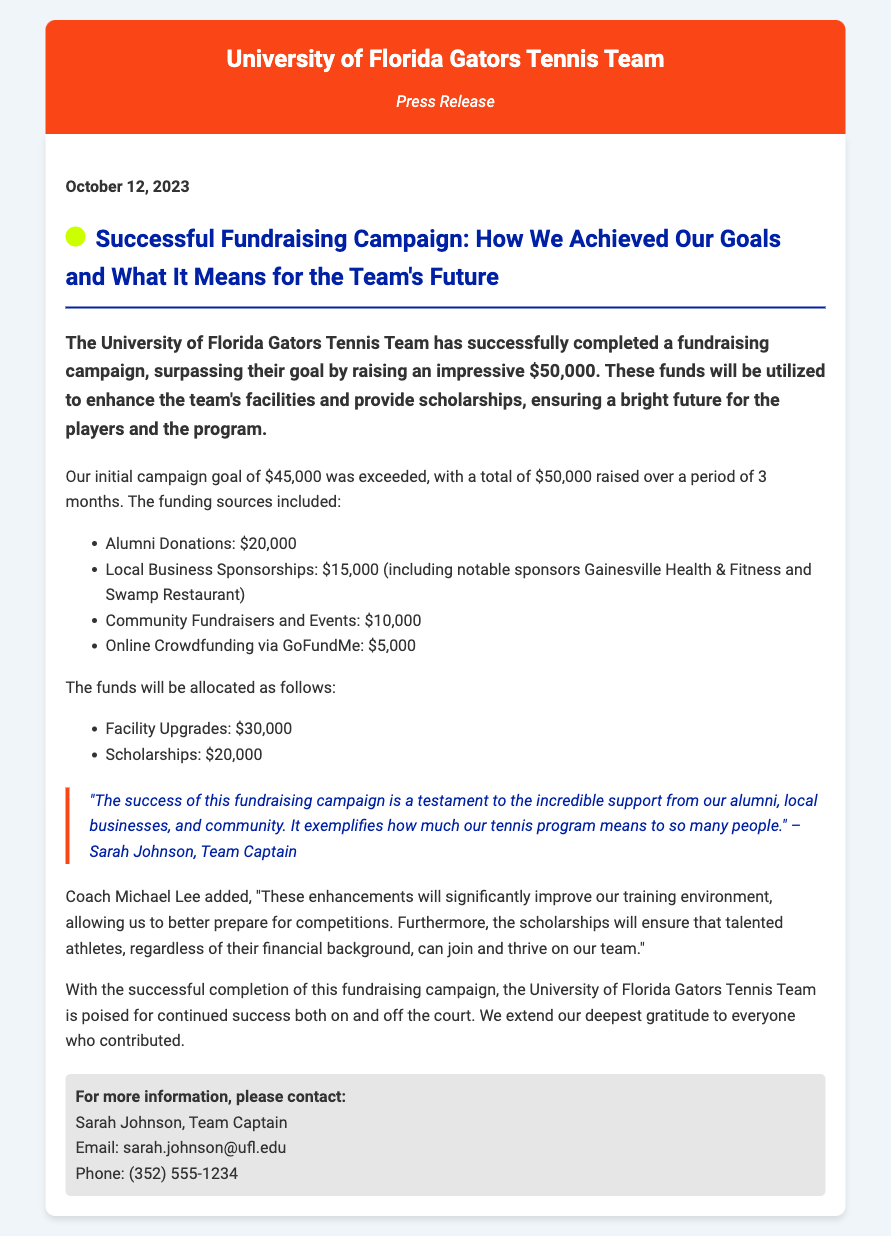what was the initial campaign goal? The document states that the initial campaign goal was $45,000.
Answer: $45,000 how much did alumni donations contribute? The document specifies that alumni donations contributed $20,000.
Answer: $20,000 who is the team captain? The team captain's name is mentioned in the document as Sarah Johnson.
Answer: Sarah Johnson what will the total funding for scholarships be? The document indicates that the total funding for scholarships will be $20,000.
Answer: $20,000 how long did the fundraising campaign last? It is stated that the fundraising campaign lasted for a period of 3 months.
Answer: 3 months what does the success of the campaign demonstrate? The quote mentions that the success demonstrates incredible support from alumni, local businesses, and the community.
Answer: Incredible support what will the majority of the funds be allocated for? The majority of the funds, $30,000, will be allocated for facility upgrades.
Answer: Facility upgrades what is the date of the press release? The date provided in the press release is October 12, 2023.
Answer: October 12, 2023 how much was raised in total? The document states that a total of $50,000 was raised during the campaign.
Answer: $50,000 